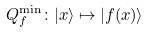Convert formula to latex. <formula><loc_0><loc_0><loc_500><loc_500>Q _ { f } ^ { \min } \colon | x \rangle \mapsto | f ( x ) \rangle</formula> 